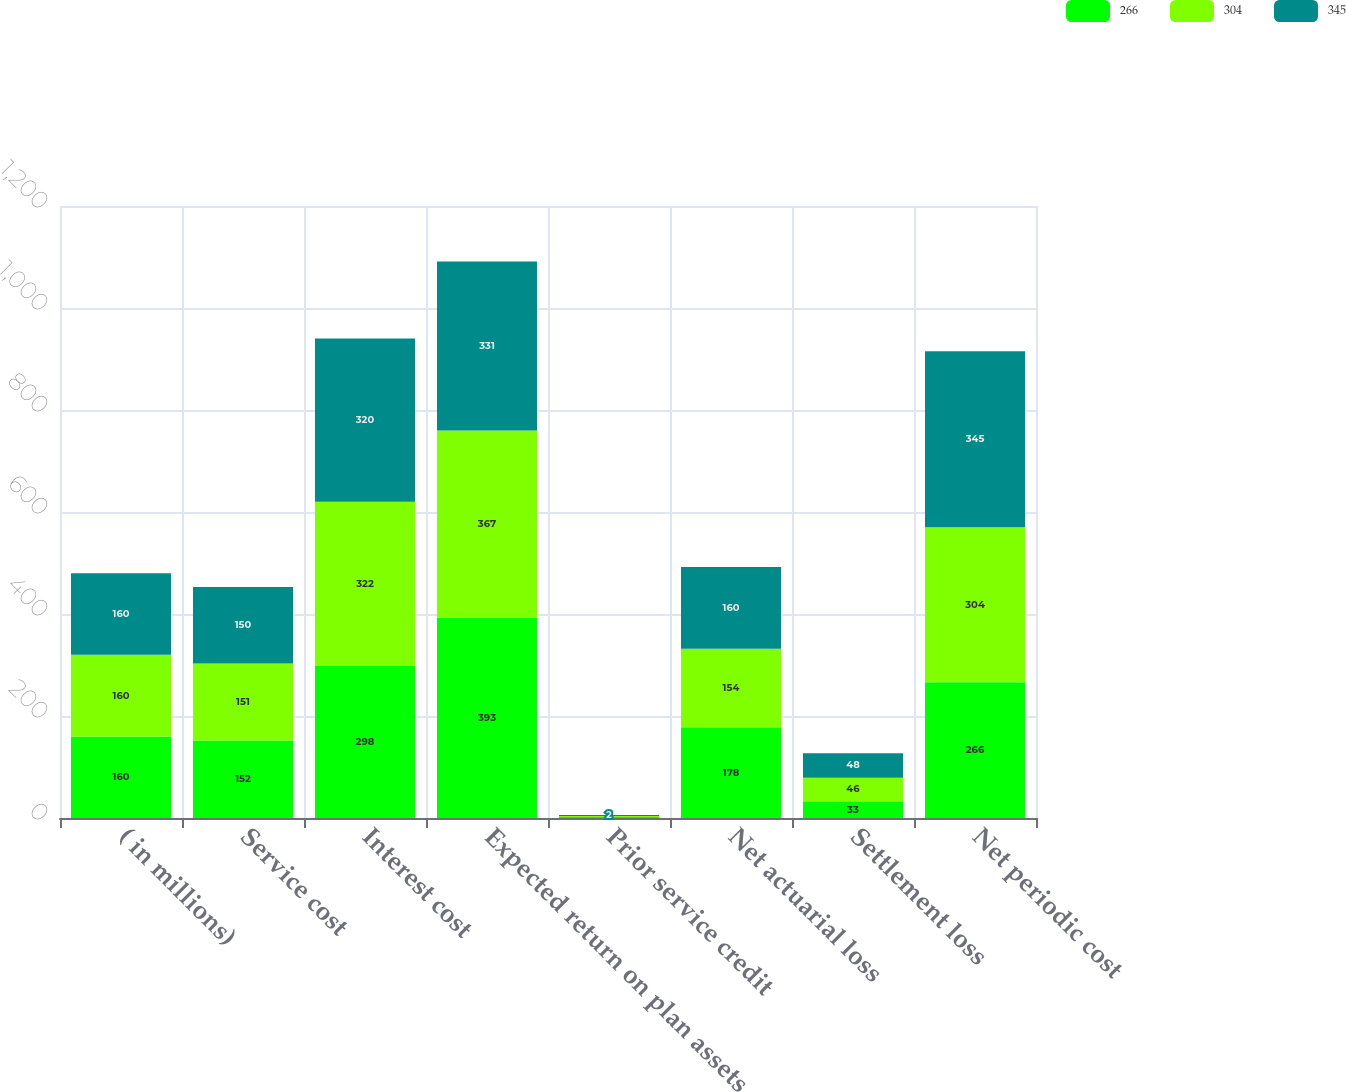<chart> <loc_0><loc_0><loc_500><loc_500><stacked_bar_chart><ecel><fcel>( in millions)<fcel>Service cost<fcel>Interest cost<fcel>Expected return on plan assets<fcel>Prior service credit<fcel>Net actuarial loss<fcel>Settlement loss<fcel>Net periodic cost<nl><fcel>266<fcel>160<fcel>152<fcel>298<fcel>393<fcel>2<fcel>178<fcel>33<fcel>266<nl><fcel>304<fcel>160<fcel>151<fcel>322<fcel>367<fcel>2<fcel>154<fcel>46<fcel>304<nl><fcel>345<fcel>160<fcel>150<fcel>320<fcel>331<fcel>2<fcel>160<fcel>48<fcel>345<nl></chart> 